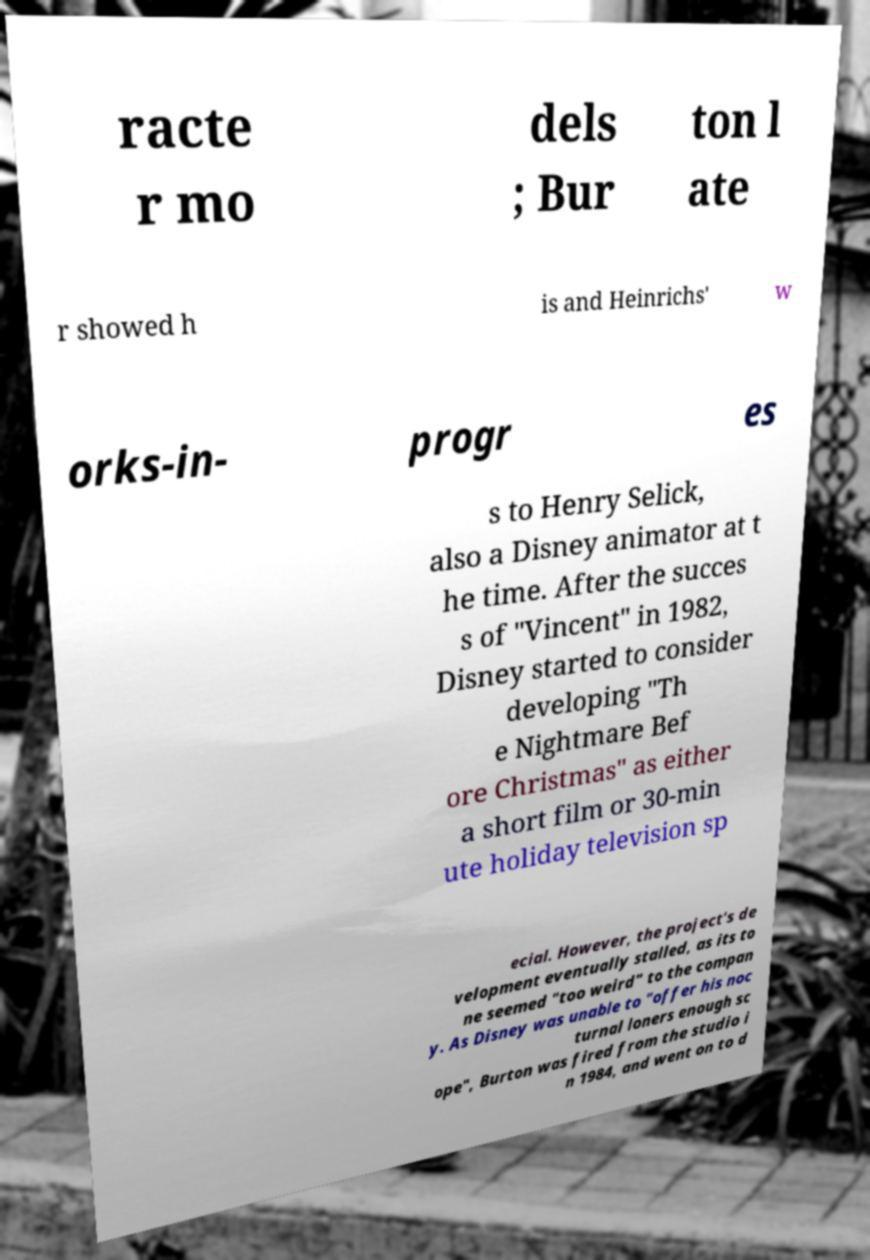Could you extract and type out the text from this image? racte r mo dels ; Bur ton l ate r showed h is and Heinrichs' w orks-in- progr es s to Henry Selick, also a Disney animator at t he time. After the succes s of "Vincent" in 1982, Disney started to consider developing "Th e Nightmare Bef ore Christmas" as either a short film or 30-min ute holiday television sp ecial. However, the project's de velopment eventually stalled, as its to ne seemed "too weird" to the compan y. As Disney was unable to "offer his noc turnal loners enough sc ope", Burton was fired from the studio i n 1984, and went on to d 